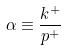<formula> <loc_0><loc_0><loc_500><loc_500>\alpha \equiv \frac { k ^ { + } } { p ^ { + } }</formula> 